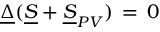<formula> <loc_0><loc_0><loc_500><loc_500>\underline { \Delta } ( \underline { S } + \underline { S } _ { P V } ) \, = \, 0</formula> 